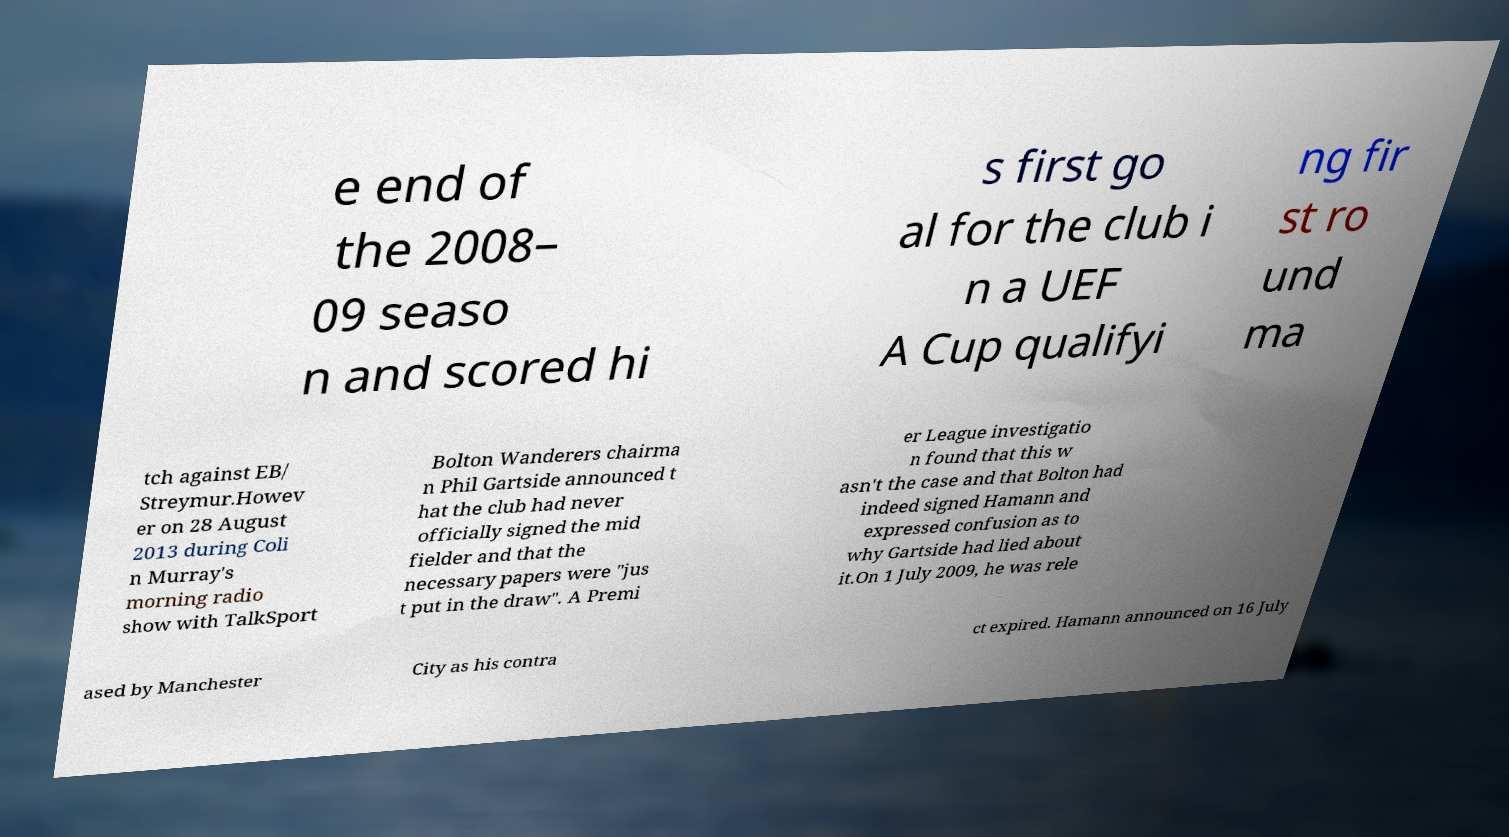For documentation purposes, I need the text within this image transcribed. Could you provide that? e end of the 2008– 09 seaso n and scored hi s first go al for the club i n a UEF A Cup qualifyi ng fir st ro und ma tch against EB/ Streymur.Howev er on 28 August 2013 during Coli n Murray's morning radio show with TalkSport Bolton Wanderers chairma n Phil Gartside announced t hat the club had never officially signed the mid fielder and that the necessary papers were "jus t put in the draw". A Premi er League investigatio n found that this w asn't the case and that Bolton had indeed signed Hamann and expressed confusion as to why Gartside had lied about it.On 1 July 2009, he was rele ased by Manchester City as his contra ct expired. Hamann announced on 16 July 